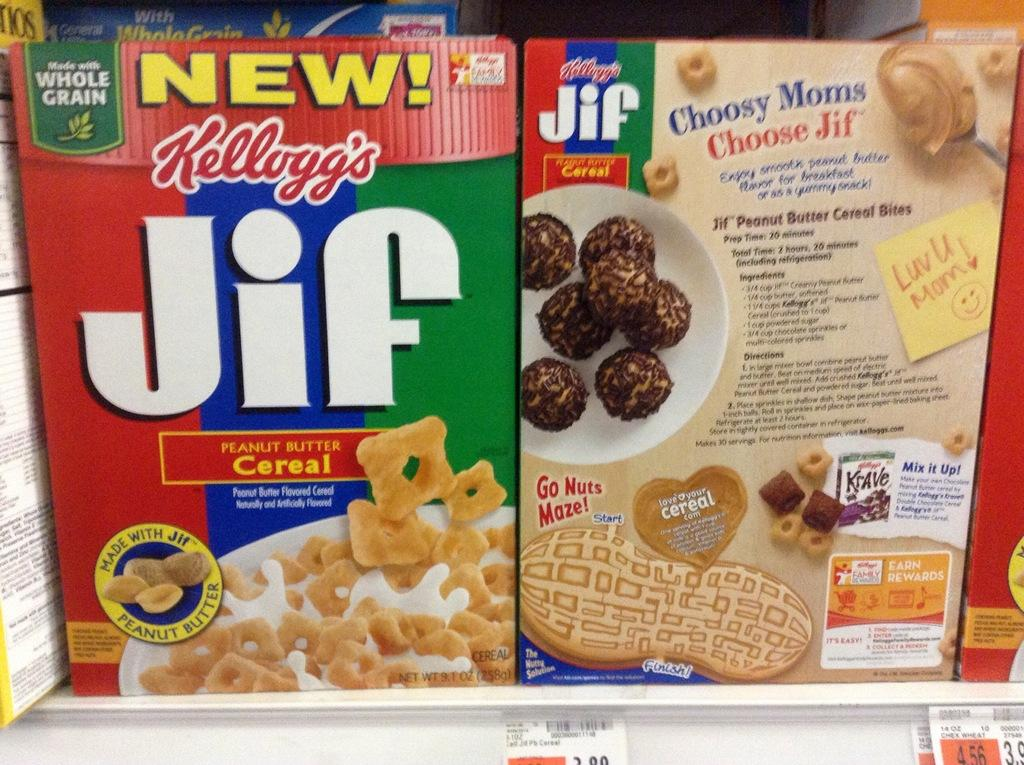What objects are present in the image? There are boxes in the image. What can be found on the boxes? There is text written on the boxes. What type of shoe is being used by the carpenter in the image? There is no carpenter or shoe present in the image; it only features boxes with text on them. 